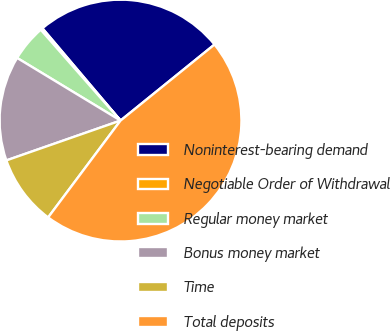<chart> <loc_0><loc_0><loc_500><loc_500><pie_chart><fcel>Noninterest-bearing demand<fcel>Negotiable Order of Withdrawal<fcel>Regular money market<fcel>Bonus money market<fcel>Time<fcel>Total deposits<nl><fcel>25.35%<fcel>0.29%<fcel>4.86%<fcel>14.01%<fcel>9.44%<fcel>46.04%<nl></chart> 